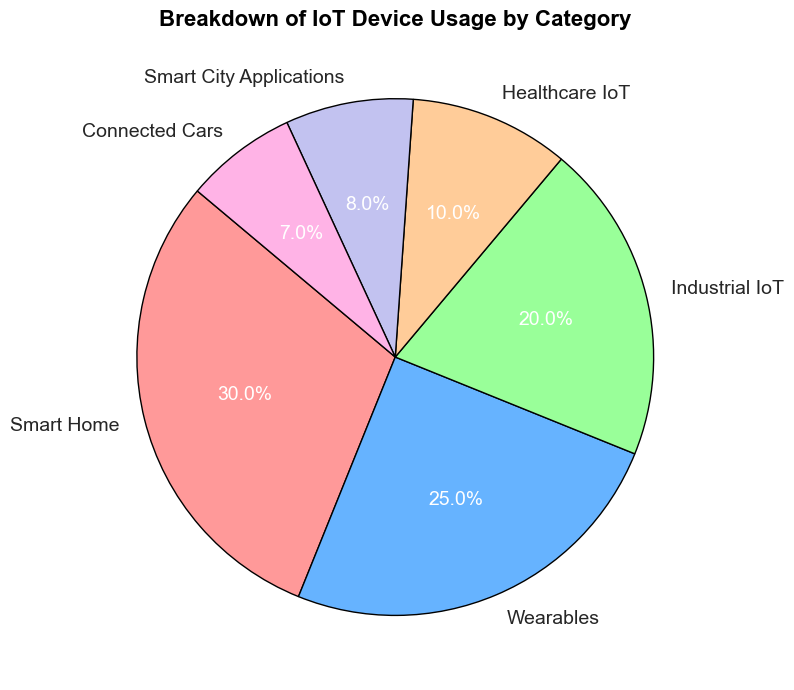What percentage of IoT devices are used in healthcare? The slice labeled "Healthcare IoT" represents the percentage of IoT devices used in healthcare. The label indicates that healthcare IoT devices constitute 10% of the total IoT device usage.
Answer: 10% Which category has the highest usage of IoT devices? The largest slice in the pie chart represents the category with the highest percentage. The slice labeled "Smart Home" is the largest, indicating that it has the highest usage at 30%.
Answer: Smart Home How much higher is the usage of Smart Home IoT devices compared to Wearables? "Smart Home" devices constitute 30%, and "Wearables" make up 25%. To find the difference, subtract 25% from 30%, resulting in a 5% higher usage for Smart Home devices compared to Wearables.
Answer: 5% What's the combined percentage of IoT devices in Smart City Applications and Connected Cars? The percentages for Smart City Applications and Connected Cars are 8% and 7%, respectively. Adding these together: 8% + 7% = 15%.
Answer: 15% Which category has a smaller usage percentage: Industrial IoT or Smart City Applications? The slices labeled "Industrial IoT" and "Smart City Applications" represent the respective percentages. "Industrial IoT" has 20%, and "Smart City Applications" has 8%. Therefore, Smart City Applications has a smaller usage percentage.
Answer: Smart City Applications What is the total percentage of IoT devices used in Smart Home, Wearables, and Industrial IoT combined? Summing the percentages of Smart Home (30%), Wearables (25%), and Industrial IoT (20%): 30% + 25% + 20% = 75%.
Answer: 75% Which category represents the smallest usage of IoT devices, and what percentage does it hold? The smallest slice in the pie chart corresponds to the category with the lowest percentage. The slice labeled "Connected Cars" is the smallest, representing 7% of IoT device usage.
Answer: Connected Cars, 7% Are Smart City Applications and Healthcare IoT combined usage greater than Wearables alone? The percentage for Smart City Applications is 8%, and Healthcare IoT is 10%. Their combined usage is 8% + 10% = 18%, which is indeed greater than the 25% usage of Wearables.
Answer: Yes Which categories together make up exactly 50% of IoT device usage? To find categories that sum up to 50%, we need to identify a combination of percentages that equals 50%. Smart Home (30%) and Wearables (25%) together make up 55%, which is too high. Smart Home (30%) and Industrial IoT (20%) combined make up exactly 50%.
Answer: Smart Home and Industrial IoT 